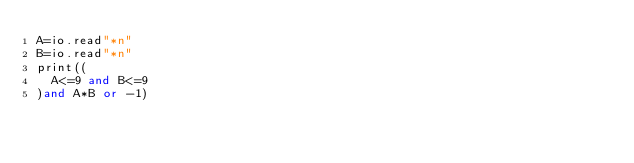<code> <loc_0><loc_0><loc_500><loc_500><_Lua_>A=io.read"*n"
B=io.read"*n"
print((
	A<=9 and B<=9
)and A*B or -1)</code> 